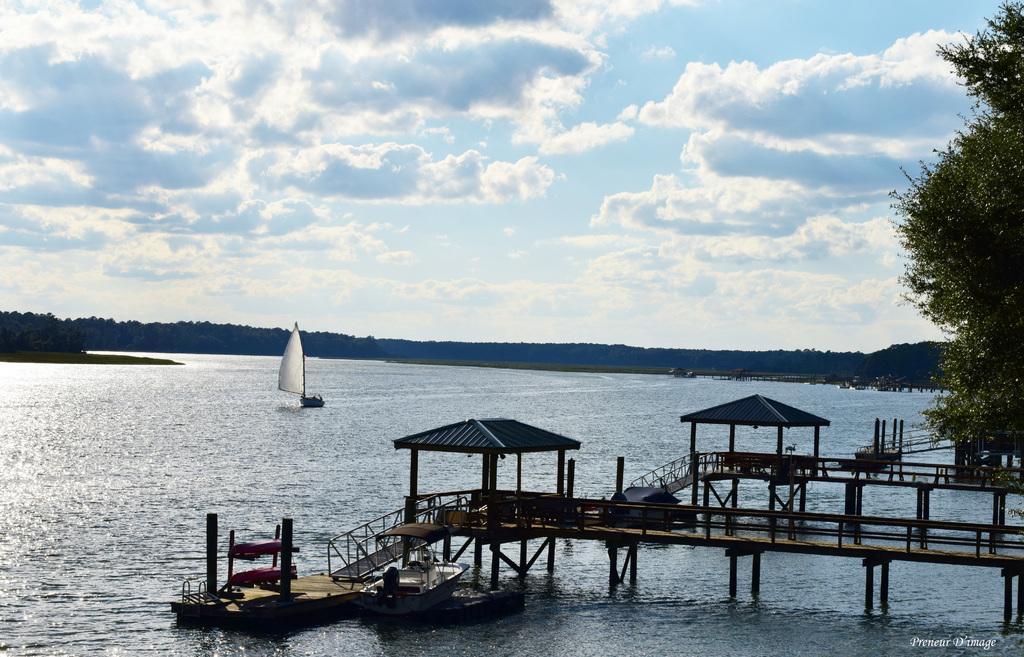Could you give a brief overview of what you see in this image? In this image at the bottom, there are boats, bridges. On the right there are trees. At the bottom there are waves, water, text. In the middle there are hills, boat, sky and clouds. 